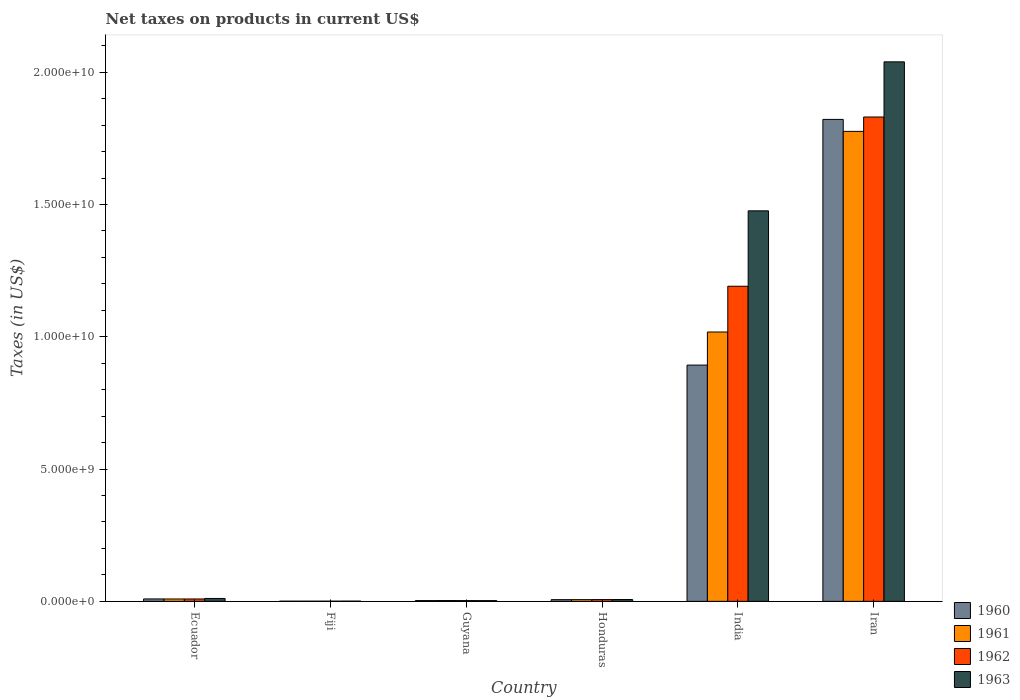How many groups of bars are there?
Offer a very short reply. 6. Are the number of bars per tick equal to the number of legend labels?
Keep it short and to the point. Yes. Are the number of bars on each tick of the X-axis equal?
Make the answer very short. Yes. What is the label of the 2nd group of bars from the left?
Keep it short and to the point. Fiji. In how many cases, is the number of bars for a given country not equal to the number of legend labels?
Make the answer very short. 0. What is the net taxes on products in 1963 in Guyana?
Offer a very short reply. 2.82e+07. Across all countries, what is the maximum net taxes on products in 1961?
Keep it short and to the point. 1.78e+1. Across all countries, what is the minimum net taxes on products in 1963?
Make the answer very short. 8.90e+06. In which country was the net taxes on products in 1961 maximum?
Provide a short and direct response. Iran. In which country was the net taxes on products in 1963 minimum?
Provide a succinct answer. Fiji. What is the total net taxes on products in 1960 in the graph?
Make the answer very short. 2.73e+1. What is the difference between the net taxes on products in 1962 in Guyana and that in Honduras?
Offer a very short reply. -3.83e+07. What is the difference between the net taxes on products in 1960 in Iran and the net taxes on products in 1962 in Fiji?
Ensure brevity in your answer.  1.82e+1. What is the average net taxes on products in 1961 per country?
Make the answer very short. 4.69e+09. What is the difference between the net taxes on products of/in 1963 and net taxes on products of/in 1961 in Iran?
Offer a very short reply. 2.63e+09. What is the ratio of the net taxes on products in 1962 in Ecuador to that in Guyana?
Provide a succinct answer. 3.11. What is the difference between the highest and the second highest net taxes on products in 1963?
Provide a succinct answer. 1.47e+1. What is the difference between the highest and the lowest net taxes on products in 1961?
Offer a terse response. 1.78e+1. Is it the case that in every country, the sum of the net taxes on products in 1962 and net taxes on products in 1961 is greater than the sum of net taxes on products in 1960 and net taxes on products in 1963?
Offer a very short reply. No. Is it the case that in every country, the sum of the net taxes on products in 1960 and net taxes on products in 1961 is greater than the net taxes on products in 1963?
Give a very brief answer. Yes. How many bars are there?
Ensure brevity in your answer.  24. Are all the bars in the graph horizontal?
Ensure brevity in your answer.  No. Are the values on the major ticks of Y-axis written in scientific E-notation?
Ensure brevity in your answer.  Yes. Does the graph contain grids?
Keep it short and to the point. No. What is the title of the graph?
Provide a short and direct response. Net taxes on products in current US$. What is the label or title of the X-axis?
Your response must be concise. Country. What is the label or title of the Y-axis?
Your answer should be very brief. Taxes (in US$). What is the Taxes (in US$) of 1960 in Ecuador?
Offer a very short reply. 9.19e+07. What is the Taxes (in US$) of 1961 in Ecuador?
Give a very brief answer. 9.02e+07. What is the Taxes (in US$) of 1962 in Ecuador?
Your response must be concise. 9.02e+07. What is the Taxes (in US$) in 1963 in Ecuador?
Keep it short and to the point. 1.10e+08. What is the Taxes (in US$) of 1960 in Fiji?
Offer a very short reply. 6.80e+06. What is the Taxes (in US$) in 1961 in Fiji?
Ensure brevity in your answer.  6.80e+06. What is the Taxes (in US$) of 1962 in Fiji?
Your answer should be very brief. 7.40e+06. What is the Taxes (in US$) of 1963 in Fiji?
Offer a terse response. 8.90e+06. What is the Taxes (in US$) in 1960 in Guyana?
Your answer should be compact. 2.94e+07. What is the Taxes (in US$) of 1961 in Guyana?
Offer a very short reply. 3.07e+07. What is the Taxes (in US$) in 1962 in Guyana?
Your response must be concise. 2.90e+07. What is the Taxes (in US$) in 1963 in Guyana?
Your answer should be very brief. 2.82e+07. What is the Taxes (in US$) of 1960 in Honduras?
Offer a terse response. 6.45e+07. What is the Taxes (in US$) in 1961 in Honduras?
Make the answer very short. 6.50e+07. What is the Taxes (in US$) of 1962 in Honduras?
Provide a succinct answer. 6.73e+07. What is the Taxes (in US$) in 1963 in Honduras?
Ensure brevity in your answer.  6.96e+07. What is the Taxes (in US$) in 1960 in India?
Your response must be concise. 8.93e+09. What is the Taxes (in US$) of 1961 in India?
Your answer should be compact. 1.02e+1. What is the Taxes (in US$) in 1962 in India?
Provide a short and direct response. 1.19e+1. What is the Taxes (in US$) of 1963 in India?
Your response must be concise. 1.48e+1. What is the Taxes (in US$) in 1960 in Iran?
Give a very brief answer. 1.82e+1. What is the Taxes (in US$) in 1961 in Iran?
Ensure brevity in your answer.  1.78e+1. What is the Taxes (in US$) of 1962 in Iran?
Your answer should be compact. 1.83e+1. What is the Taxes (in US$) in 1963 in Iran?
Ensure brevity in your answer.  2.04e+1. Across all countries, what is the maximum Taxes (in US$) of 1960?
Provide a succinct answer. 1.82e+1. Across all countries, what is the maximum Taxes (in US$) of 1961?
Provide a short and direct response. 1.78e+1. Across all countries, what is the maximum Taxes (in US$) in 1962?
Your answer should be very brief. 1.83e+1. Across all countries, what is the maximum Taxes (in US$) in 1963?
Your response must be concise. 2.04e+1. Across all countries, what is the minimum Taxes (in US$) of 1960?
Ensure brevity in your answer.  6.80e+06. Across all countries, what is the minimum Taxes (in US$) in 1961?
Keep it short and to the point. 6.80e+06. Across all countries, what is the minimum Taxes (in US$) in 1962?
Provide a succinct answer. 7.40e+06. Across all countries, what is the minimum Taxes (in US$) of 1963?
Ensure brevity in your answer.  8.90e+06. What is the total Taxes (in US$) in 1960 in the graph?
Offer a very short reply. 2.73e+1. What is the total Taxes (in US$) in 1961 in the graph?
Ensure brevity in your answer.  2.81e+1. What is the total Taxes (in US$) of 1962 in the graph?
Your answer should be compact. 3.04e+1. What is the total Taxes (in US$) in 1963 in the graph?
Make the answer very short. 3.54e+1. What is the difference between the Taxes (in US$) in 1960 in Ecuador and that in Fiji?
Your response must be concise. 8.51e+07. What is the difference between the Taxes (in US$) in 1961 in Ecuador and that in Fiji?
Your response must be concise. 8.34e+07. What is the difference between the Taxes (in US$) in 1962 in Ecuador and that in Fiji?
Offer a terse response. 8.28e+07. What is the difference between the Taxes (in US$) in 1963 in Ecuador and that in Fiji?
Make the answer very short. 1.01e+08. What is the difference between the Taxes (in US$) in 1960 in Ecuador and that in Guyana?
Ensure brevity in your answer.  6.25e+07. What is the difference between the Taxes (in US$) in 1961 in Ecuador and that in Guyana?
Your response must be concise. 5.95e+07. What is the difference between the Taxes (in US$) of 1962 in Ecuador and that in Guyana?
Your response must be concise. 6.12e+07. What is the difference between the Taxes (in US$) of 1963 in Ecuador and that in Guyana?
Your response must be concise. 8.15e+07. What is the difference between the Taxes (in US$) in 1960 in Ecuador and that in Honduras?
Ensure brevity in your answer.  2.74e+07. What is the difference between the Taxes (in US$) of 1961 in Ecuador and that in Honduras?
Provide a succinct answer. 2.52e+07. What is the difference between the Taxes (in US$) in 1962 in Ecuador and that in Honduras?
Your answer should be compact. 2.29e+07. What is the difference between the Taxes (in US$) in 1963 in Ecuador and that in Honduras?
Your response must be concise. 4.01e+07. What is the difference between the Taxes (in US$) in 1960 in Ecuador and that in India?
Your answer should be very brief. -8.84e+09. What is the difference between the Taxes (in US$) of 1961 in Ecuador and that in India?
Your answer should be compact. -1.01e+1. What is the difference between the Taxes (in US$) of 1962 in Ecuador and that in India?
Your response must be concise. -1.18e+1. What is the difference between the Taxes (in US$) in 1963 in Ecuador and that in India?
Give a very brief answer. -1.47e+1. What is the difference between the Taxes (in US$) of 1960 in Ecuador and that in Iran?
Keep it short and to the point. -1.81e+1. What is the difference between the Taxes (in US$) of 1961 in Ecuador and that in Iran?
Provide a short and direct response. -1.77e+1. What is the difference between the Taxes (in US$) in 1962 in Ecuador and that in Iran?
Keep it short and to the point. -1.82e+1. What is the difference between the Taxes (in US$) of 1963 in Ecuador and that in Iran?
Make the answer very short. -2.03e+1. What is the difference between the Taxes (in US$) of 1960 in Fiji and that in Guyana?
Your answer should be very brief. -2.26e+07. What is the difference between the Taxes (in US$) in 1961 in Fiji and that in Guyana?
Keep it short and to the point. -2.39e+07. What is the difference between the Taxes (in US$) of 1962 in Fiji and that in Guyana?
Offer a terse response. -2.16e+07. What is the difference between the Taxes (in US$) in 1963 in Fiji and that in Guyana?
Your answer should be very brief. -1.93e+07. What is the difference between the Taxes (in US$) of 1960 in Fiji and that in Honduras?
Ensure brevity in your answer.  -5.77e+07. What is the difference between the Taxes (in US$) in 1961 in Fiji and that in Honduras?
Your answer should be very brief. -5.82e+07. What is the difference between the Taxes (in US$) of 1962 in Fiji and that in Honduras?
Provide a succinct answer. -5.99e+07. What is the difference between the Taxes (in US$) in 1963 in Fiji and that in Honduras?
Keep it short and to the point. -6.07e+07. What is the difference between the Taxes (in US$) in 1960 in Fiji and that in India?
Your response must be concise. -8.92e+09. What is the difference between the Taxes (in US$) in 1961 in Fiji and that in India?
Make the answer very short. -1.02e+1. What is the difference between the Taxes (in US$) of 1962 in Fiji and that in India?
Your response must be concise. -1.19e+1. What is the difference between the Taxes (in US$) in 1963 in Fiji and that in India?
Keep it short and to the point. -1.48e+1. What is the difference between the Taxes (in US$) of 1960 in Fiji and that in Iran?
Make the answer very short. -1.82e+1. What is the difference between the Taxes (in US$) in 1961 in Fiji and that in Iran?
Make the answer very short. -1.78e+1. What is the difference between the Taxes (in US$) of 1962 in Fiji and that in Iran?
Your response must be concise. -1.83e+1. What is the difference between the Taxes (in US$) in 1963 in Fiji and that in Iran?
Your response must be concise. -2.04e+1. What is the difference between the Taxes (in US$) in 1960 in Guyana and that in Honduras?
Give a very brief answer. -3.51e+07. What is the difference between the Taxes (in US$) in 1961 in Guyana and that in Honduras?
Your response must be concise. -3.43e+07. What is the difference between the Taxes (in US$) in 1962 in Guyana and that in Honduras?
Give a very brief answer. -3.83e+07. What is the difference between the Taxes (in US$) of 1963 in Guyana and that in Honduras?
Offer a very short reply. -4.14e+07. What is the difference between the Taxes (in US$) in 1960 in Guyana and that in India?
Offer a very short reply. -8.90e+09. What is the difference between the Taxes (in US$) of 1961 in Guyana and that in India?
Offer a very short reply. -1.01e+1. What is the difference between the Taxes (in US$) of 1962 in Guyana and that in India?
Your answer should be very brief. -1.19e+1. What is the difference between the Taxes (in US$) of 1963 in Guyana and that in India?
Your answer should be compact. -1.47e+1. What is the difference between the Taxes (in US$) of 1960 in Guyana and that in Iran?
Provide a short and direct response. -1.82e+1. What is the difference between the Taxes (in US$) in 1961 in Guyana and that in Iran?
Your answer should be very brief. -1.77e+1. What is the difference between the Taxes (in US$) in 1962 in Guyana and that in Iran?
Make the answer very short. -1.83e+1. What is the difference between the Taxes (in US$) of 1963 in Guyana and that in Iran?
Your answer should be very brief. -2.04e+1. What is the difference between the Taxes (in US$) of 1960 in Honduras and that in India?
Provide a succinct answer. -8.87e+09. What is the difference between the Taxes (in US$) of 1961 in Honduras and that in India?
Your answer should be very brief. -1.01e+1. What is the difference between the Taxes (in US$) in 1962 in Honduras and that in India?
Provide a succinct answer. -1.18e+1. What is the difference between the Taxes (in US$) in 1963 in Honduras and that in India?
Your answer should be compact. -1.47e+1. What is the difference between the Taxes (in US$) of 1960 in Honduras and that in Iran?
Ensure brevity in your answer.  -1.82e+1. What is the difference between the Taxes (in US$) in 1961 in Honduras and that in Iran?
Provide a short and direct response. -1.77e+1. What is the difference between the Taxes (in US$) in 1962 in Honduras and that in Iran?
Your response must be concise. -1.82e+1. What is the difference between the Taxes (in US$) in 1963 in Honduras and that in Iran?
Your answer should be compact. -2.03e+1. What is the difference between the Taxes (in US$) of 1960 in India and that in Iran?
Provide a short and direct response. -9.29e+09. What is the difference between the Taxes (in US$) in 1961 in India and that in Iran?
Provide a succinct answer. -7.58e+09. What is the difference between the Taxes (in US$) of 1962 in India and that in Iran?
Your answer should be very brief. -6.40e+09. What is the difference between the Taxes (in US$) of 1963 in India and that in Iran?
Provide a short and direct response. -5.63e+09. What is the difference between the Taxes (in US$) in 1960 in Ecuador and the Taxes (in US$) in 1961 in Fiji?
Offer a very short reply. 8.51e+07. What is the difference between the Taxes (in US$) of 1960 in Ecuador and the Taxes (in US$) of 1962 in Fiji?
Offer a very short reply. 8.45e+07. What is the difference between the Taxes (in US$) of 1960 in Ecuador and the Taxes (in US$) of 1963 in Fiji?
Ensure brevity in your answer.  8.30e+07. What is the difference between the Taxes (in US$) of 1961 in Ecuador and the Taxes (in US$) of 1962 in Fiji?
Provide a short and direct response. 8.28e+07. What is the difference between the Taxes (in US$) of 1961 in Ecuador and the Taxes (in US$) of 1963 in Fiji?
Make the answer very short. 8.13e+07. What is the difference between the Taxes (in US$) of 1962 in Ecuador and the Taxes (in US$) of 1963 in Fiji?
Keep it short and to the point. 8.13e+07. What is the difference between the Taxes (in US$) in 1960 in Ecuador and the Taxes (in US$) in 1961 in Guyana?
Offer a terse response. 6.12e+07. What is the difference between the Taxes (in US$) of 1960 in Ecuador and the Taxes (in US$) of 1962 in Guyana?
Your response must be concise. 6.29e+07. What is the difference between the Taxes (in US$) in 1960 in Ecuador and the Taxes (in US$) in 1963 in Guyana?
Provide a succinct answer. 6.37e+07. What is the difference between the Taxes (in US$) of 1961 in Ecuador and the Taxes (in US$) of 1962 in Guyana?
Provide a succinct answer. 6.12e+07. What is the difference between the Taxes (in US$) in 1961 in Ecuador and the Taxes (in US$) in 1963 in Guyana?
Ensure brevity in your answer.  6.20e+07. What is the difference between the Taxes (in US$) in 1962 in Ecuador and the Taxes (in US$) in 1963 in Guyana?
Your response must be concise. 6.20e+07. What is the difference between the Taxes (in US$) in 1960 in Ecuador and the Taxes (in US$) in 1961 in Honduras?
Provide a short and direct response. 2.69e+07. What is the difference between the Taxes (in US$) of 1960 in Ecuador and the Taxes (in US$) of 1962 in Honduras?
Your answer should be very brief. 2.46e+07. What is the difference between the Taxes (in US$) in 1960 in Ecuador and the Taxes (in US$) in 1963 in Honduras?
Your answer should be very brief. 2.23e+07. What is the difference between the Taxes (in US$) in 1961 in Ecuador and the Taxes (in US$) in 1962 in Honduras?
Offer a terse response. 2.29e+07. What is the difference between the Taxes (in US$) of 1961 in Ecuador and the Taxes (in US$) of 1963 in Honduras?
Give a very brief answer. 2.06e+07. What is the difference between the Taxes (in US$) of 1962 in Ecuador and the Taxes (in US$) of 1963 in Honduras?
Keep it short and to the point. 2.06e+07. What is the difference between the Taxes (in US$) in 1960 in Ecuador and the Taxes (in US$) in 1961 in India?
Make the answer very short. -1.01e+1. What is the difference between the Taxes (in US$) in 1960 in Ecuador and the Taxes (in US$) in 1962 in India?
Your answer should be compact. -1.18e+1. What is the difference between the Taxes (in US$) in 1960 in Ecuador and the Taxes (in US$) in 1963 in India?
Keep it short and to the point. -1.47e+1. What is the difference between the Taxes (in US$) in 1961 in Ecuador and the Taxes (in US$) in 1962 in India?
Your answer should be compact. -1.18e+1. What is the difference between the Taxes (in US$) of 1961 in Ecuador and the Taxes (in US$) of 1963 in India?
Provide a succinct answer. -1.47e+1. What is the difference between the Taxes (in US$) in 1962 in Ecuador and the Taxes (in US$) in 1963 in India?
Provide a succinct answer. -1.47e+1. What is the difference between the Taxes (in US$) in 1960 in Ecuador and the Taxes (in US$) in 1961 in Iran?
Your answer should be very brief. -1.77e+1. What is the difference between the Taxes (in US$) of 1960 in Ecuador and the Taxes (in US$) of 1962 in Iran?
Provide a succinct answer. -1.82e+1. What is the difference between the Taxes (in US$) of 1960 in Ecuador and the Taxes (in US$) of 1963 in Iran?
Offer a terse response. -2.03e+1. What is the difference between the Taxes (in US$) in 1961 in Ecuador and the Taxes (in US$) in 1962 in Iran?
Give a very brief answer. -1.82e+1. What is the difference between the Taxes (in US$) of 1961 in Ecuador and the Taxes (in US$) of 1963 in Iran?
Provide a succinct answer. -2.03e+1. What is the difference between the Taxes (in US$) of 1962 in Ecuador and the Taxes (in US$) of 1963 in Iran?
Ensure brevity in your answer.  -2.03e+1. What is the difference between the Taxes (in US$) of 1960 in Fiji and the Taxes (in US$) of 1961 in Guyana?
Your response must be concise. -2.39e+07. What is the difference between the Taxes (in US$) of 1960 in Fiji and the Taxes (in US$) of 1962 in Guyana?
Offer a very short reply. -2.22e+07. What is the difference between the Taxes (in US$) in 1960 in Fiji and the Taxes (in US$) in 1963 in Guyana?
Keep it short and to the point. -2.14e+07. What is the difference between the Taxes (in US$) of 1961 in Fiji and the Taxes (in US$) of 1962 in Guyana?
Your response must be concise. -2.22e+07. What is the difference between the Taxes (in US$) in 1961 in Fiji and the Taxes (in US$) in 1963 in Guyana?
Offer a terse response. -2.14e+07. What is the difference between the Taxes (in US$) of 1962 in Fiji and the Taxes (in US$) of 1963 in Guyana?
Give a very brief answer. -2.08e+07. What is the difference between the Taxes (in US$) of 1960 in Fiji and the Taxes (in US$) of 1961 in Honduras?
Make the answer very short. -5.82e+07. What is the difference between the Taxes (in US$) in 1960 in Fiji and the Taxes (in US$) in 1962 in Honduras?
Offer a very short reply. -6.05e+07. What is the difference between the Taxes (in US$) of 1960 in Fiji and the Taxes (in US$) of 1963 in Honduras?
Your answer should be very brief. -6.28e+07. What is the difference between the Taxes (in US$) in 1961 in Fiji and the Taxes (in US$) in 1962 in Honduras?
Provide a short and direct response. -6.05e+07. What is the difference between the Taxes (in US$) of 1961 in Fiji and the Taxes (in US$) of 1963 in Honduras?
Offer a very short reply. -6.28e+07. What is the difference between the Taxes (in US$) in 1962 in Fiji and the Taxes (in US$) in 1963 in Honduras?
Your response must be concise. -6.22e+07. What is the difference between the Taxes (in US$) of 1960 in Fiji and the Taxes (in US$) of 1961 in India?
Your answer should be very brief. -1.02e+1. What is the difference between the Taxes (in US$) in 1960 in Fiji and the Taxes (in US$) in 1962 in India?
Provide a succinct answer. -1.19e+1. What is the difference between the Taxes (in US$) in 1960 in Fiji and the Taxes (in US$) in 1963 in India?
Give a very brief answer. -1.48e+1. What is the difference between the Taxes (in US$) in 1961 in Fiji and the Taxes (in US$) in 1962 in India?
Ensure brevity in your answer.  -1.19e+1. What is the difference between the Taxes (in US$) in 1961 in Fiji and the Taxes (in US$) in 1963 in India?
Your answer should be compact. -1.48e+1. What is the difference between the Taxes (in US$) in 1962 in Fiji and the Taxes (in US$) in 1963 in India?
Offer a very short reply. -1.48e+1. What is the difference between the Taxes (in US$) of 1960 in Fiji and the Taxes (in US$) of 1961 in Iran?
Your response must be concise. -1.78e+1. What is the difference between the Taxes (in US$) of 1960 in Fiji and the Taxes (in US$) of 1962 in Iran?
Provide a succinct answer. -1.83e+1. What is the difference between the Taxes (in US$) in 1960 in Fiji and the Taxes (in US$) in 1963 in Iran?
Offer a very short reply. -2.04e+1. What is the difference between the Taxes (in US$) in 1961 in Fiji and the Taxes (in US$) in 1962 in Iran?
Provide a succinct answer. -1.83e+1. What is the difference between the Taxes (in US$) in 1961 in Fiji and the Taxes (in US$) in 1963 in Iran?
Make the answer very short. -2.04e+1. What is the difference between the Taxes (in US$) in 1962 in Fiji and the Taxes (in US$) in 1963 in Iran?
Your answer should be very brief. -2.04e+1. What is the difference between the Taxes (in US$) of 1960 in Guyana and the Taxes (in US$) of 1961 in Honduras?
Your response must be concise. -3.56e+07. What is the difference between the Taxes (in US$) in 1960 in Guyana and the Taxes (in US$) in 1962 in Honduras?
Your answer should be very brief. -3.79e+07. What is the difference between the Taxes (in US$) in 1960 in Guyana and the Taxes (in US$) in 1963 in Honduras?
Provide a short and direct response. -4.02e+07. What is the difference between the Taxes (in US$) of 1961 in Guyana and the Taxes (in US$) of 1962 in Honduras?
Ensure brevity in your answer.  -3.66e+07. What is the difference between the Taxes (in US$) of 1961 in Guyana and the Taxes (in US$) of 1963 in Honduras?
Your answer should be very brief. -3.89e+07. What is the difference between the Taxes (in US$) of 1962 in Guyana and the Taxes (in US$) of 1963 in Honduras?
Keep it short and to the point. -4.06e+07. What is the difference between the Taxes (in US$) in 1960 in Guyana and the Taxes (in US$) in 1961 in India?
Provide a short and direct response. -1.02e+1. What is the difference between the Taxes (in US$) of 1960 in Guyana and the Taxes (in US$) of 1962 in India?
Provide a succinct answer. -1.19e+1. What is the difference between the Taxes (in US$) in 1960 in Guyana and the Taxes (in US$) in 1963 in India?
Provide a succinct answer. -1.47e+1. What is the difference between the Taxes (in US$) in 1961 in Guyana and the Taxes (in US$) in 1962 in India?
Give a very brief answer. -1.19e+1. What is the difference between the Taxes (in US$) of 1961 in Guyana and the Taxes (in US$) of 1963 in India?
Make the answer very short. -1.47e+1. What is the difference between the Taxes (in US$) in 1962 in Guyana and the Taxes (in US$) in 1963 in India?
Provide a short and direct response. -1.47e+1. What is the difference between the Taxes (in US$) of 1960 in Guyana and the Taxes (in US$) of 1961 in Iran?
Ensure brevity in your answer.  -1.77e+1. What is the difference between the Taxes (in US$) in 1960 in Guyana and the Taxes (in US$) in 1962 in Iran?
Give a very brief answer. -1.83e+1. What is the difference between the Taxes (in US$) in 1960 in Guyana and the Taxes (in US$) in 1963 in Iran?
Keep it short and to the point. -2.04e+1. What is the difference between the Taxes (in US$) of 1961 in Guyana and the Taxes (in US$) of 1962 in Iran?
Ensure brevity in your answer.  -1.83e+1. What is the difference between the Taxes (in US$) of 1961 in Guyana and the Taxes (in US$) of 1963 in Iran?
Your response must be concise. -2.04e+1. What is the difference between the Taxes (in US$) in 1962 in Guyana and the Taxes (in US$) in 1963 in Iran?
Give a very brief answer. -2.04e+1. What is the difference between the Taxes (in US$) in 1960 in Honduras and the Taxes (in US$) in 1961 in India?
Provide a short and direct response. -1.01e+1. What is the difference between the Taxes (in US$) of 1960 in Honduras and the Taxes (in US$) of 1962 in India?
Keep it short and to the point. -1.18e+1. What is the difference between the Taxes (in US$) of 1960 in Honduras and the Taxes (in US$) of 1963 in India?
Your answer should be very brief. -1.47e+1. What is the difference between the Taxes (in US$) in 1961 in Honduras and the Taxes (in US$) in 1962 in India?
Keep it short and to the point. -1.18e+1. What is the difference between the Taxes (in US$) of 1961 in Honduras and the Taxes (in US$) of 1963 in India?
Give a very brief answer. -1.47e+1. What is the difference between the Taxes (in US$) of 1962 in Honduras and the Taxes (in US$) of 1963 in India?
Offer a very short reply. -1.47e+1. What is the difference between the Taxes (in US$) in 1960 in Honduras and the Taxes (in US$) in 1961 in Iran?
Your answer should be compact. -1.77e+1. What is the difference between the Taxes (in US$) in 1960 in Honduras and the Taxes (in US$) in 1962 in Iran?
Give a very brief answer. -1.82e+1. What is the difference between the Taxes (in US$) of 1960 in Honduras and the Taxes (in US$) of 1963 in Iran?
Give a very brief answer. -2.03e+1. What is the difference between the Taxes (in US$) of 1961 in Honduras and the Taxes (in US$) of 1962 in Iran?
Ensure brevity in your answer.  -1.82e+1. What is the difference between the Taxes (in US$) of 1961 in Honduras and the Taxes (in US$) of 1963 in Iran?
Your answer should be compact. -2.03e+1. What is the difference between the Taxes (in US$) in 1962 in Honduras and the Taxes (in US$) in 1963 in Iran?
Provide a succinct answer. -2.03e+1. What is the difference between the Taxes (in US$) of 1960 in India and the Taxes (in US$) of 1961 in Iran?
Offer a very short reply. -8.83e+09. What is the difference between the Taxes (in US$) of 1960 in India and the Taxes (in US$) of 1962 in Iran?
Keep it short and to the point. -9.38e+09. What is the difference between the Taxes (in US$) in 1960 in India and the Taxes (in US$) in 1963 in Iran?
Provide a short and direct response. -1.15e+1. What is the difference between the Taxes (in US$) of 1961 in India and the Taxes (in US$) of 1962 in Iran?
Your answer should be very brief. -8.13e+09. What is the difference between the Taxes (in US$) in 1961 in India and the Taxes (in US$) in 1963 in Iran?
Your response must be concise. -1.02e+1. What is the difference between the Taxes (in US$) of 1962 in India and the Taxes (in US$) of 1963 in Iran?
Your answer should be very brief. -8.48e+09. What is the average Taxes (in US$) in 1960 per country?
Ensure brevity in your answer.  4.56e+09. What is the average Taxes (in US$) in 1961 per country?
Your response must be concise. 4.69e+09. What is the average Taxes (in US$) of 1962 per country?
Your response must be concise. 5.07e+09. What is the average Taxes (in US$) of 1963 per country?
Ensure brevity in your answer.  5.89e+09. What is the difference between the Taxes (in US$) in 1960 and Taxes (in US$) in 1961 in Ecuador?
Make the answer very short. 1.67e+06. What is the difference between the Taxes (in US$) of 1960 and Taxes (in US$) of 1962 in Ecuador?
Your answer should be very brief. 1.67e+06. What is the difference between the Taxes (in US$) in 1960 and Taxes (in US$) in 1963 in Ecuador?
Ensure brevity in your answer.  -1.78e+07. What is the difference between the Taxes (in US$) of 1961 and Taxes (in US$) of 1962 in Ecuador?
Offer a terse response. 0. What is the difference between the Taxes (in US$) in 1961 and Taxes (in US$) in 1963 in Ecuador?
Your response must be concise. -1.95e+07. What is the difference between the Taxes (in US$) of 1962 and Taxes (in US$) of 1963 in Ecuador?
Provide a succinct answer. -1.95e+07. What is the difference between the Taxes (in US$) of 1960 and Taxes (in US$) of 1962 in Fiji?
Give a very brief answer. -6.00e+05. What is the difference between the Taxes (in US$) in 1960 and Taxes (in US$) in 1963 in Fiji?
Keep it short and to the point. -2.10e+06. What is the difference between the Taxes (in US$) of 1961 and Taxes (in US$) of 1962 in Fiji?
Give a very brief answer. -6.00e+05. What is the difference between the Taxes (in US$) of 1961 and Taxes (in US$) of 1963 in Fiji?
Offer a terse response. -2.10e+06. What is the difference between the Taxes (in US$) in 1962 and Taxes (in US$) in 1963 in Fiji?
Provide a short and direct response. -1.50e+06. What is the difference between the Taxes (in US$) in 1960 and Taxes (in US$) in 1961 in Guyana?
Offer a very short reply. -1.30e+06. What is the difference between the Taxes (in US$) in 1960 and Taxes (in US$) in 1963 in Guyana?
Your answer should be very brief. 1.20e+06. What is the difference between the Taxes (in US$) of 1961 and Taxes (in US$) of 1962 in Guyana?
Make the answer very short. 1.70e+06. What is the difference between the Taxes (in US$) of 1961 and Taxes (in US$) of 1963 in Guyana?
Your answer should be very brief. 2.50e+06. What is the difference between the Taxes (in US$) of 1960 and Taxes (in US$) of 1961 in Honduras?
Ensure brevity in your answer.  -5.00e+05. What is the difference between the Taxes (in US$) in 1960 and Taxes (in US$) in 1962 in Honduras?
Provide a short and direct response. -2.80e+06. What is the difference between the Taxes (in US$) of 1960 and Taxes (in US$) of 1963 in Honduras?
Provide a short and direct response. -5.10e+06. What is the difference between the Taxes (in US$) in 1961 and Taxes (in US$) in 1962 in Honduras?
Make the answer very short. -2.30e+06. What is the difference between the Taxes (in US$) of 1961 and Taxes (in US$) of 1963 in Honduras?
Your response must be concise. -4.60e+06. What is the difference between the Taxes (in US$) of 1962 and Taxes (in US$) of 1963 in Honduras?
Your response must be concise. -2.30e+06. What is the difference between the Taxes (in US$) in 1960 and Taxes (in US$) in 1961 in India?
Your answer should be compact. -1.25e+09. What is the difference between the Taxes (in US$) of 1960 and Taxes (in US$) of 1962 in India?
Make the answer very short. -2.98e+09. What is the difference between the Taxes (in US$) in 1960 and Taxes (in US$) in 1963 in India?
Make the answer very short. -5.83e+09. What is the difference between the Taxes (in US$) of 1961 and Taxes (in US$) of 1962 in India?
Make the answer very short. -1.73e+09. What is the difference between the Taxes (in US$) of 1961 and Taxes (in US$) of 1963 in India?
Your answer should be compact. -4.58e+09. What is the difference between the Taxes (in US$) of 1962 and Taxes (in US$) of 1963 in India?
Keep it short and to the point. -2.85e+09. What is the difference between the Taxes (in US$) in 1960 and Taxes (in US$) in 1961 in Iran?
Ensure brevity in your answer.  4.53e+08. What is the difference between the Taxes (in US$) in 1960 and Taxes (in US$) in 1962 in Iran?
Keep it short and to the point. -9.06e+07. What is the difference between the Taxes (in US$) in 1960 and Taxes (in US$) in 1963 in Iran?
Provide a succinct answer. -2.18e+09. What is the difference between the Taxes (in US$) of 1961 and Taxes (in US$) of 1962 in Iran?
Keep it short and to the point. -5.44e+08. What is the difference between the Taxes (in US$) in 1961 and Taxes (in US$) in 1963 in Iran?
Make the answer very short. -2.63e+09. What is the difference between the Taxes (in US$) in 1962 and Taxes (in US$) in 1963 in Iran?
Your answer should be very brief. -2.08e+09. What is the ratio of the Taxes (in US$) of 1960 in Ecuador to that in Fiji?
Offer a very short reply. 13.51. What is the ratio of the Taxes (in US$) in 1961 in Ecuador to that in Fiji?
Keep it short and to the point. 13.27. What is the ratio of the Taxes (in US$) of 1962 in Ecuador to that in Fiji?
Give a very brief answer. 12.19. What is the ratio of the Taxes (in US$) of 1963 in Ecuador to that in Fiji?
Provide a succinct answer. 12.33. What is the ratio of the Taxes (in US$) of 1960 in Ecuador to that in Guyana?
Make the answer very short. 3.13. What is the ratio of the Taxes (in US$) in 1961 in Ecuador to that in Guyana?
Your answer should be very brief. 2.94. What is the ratio of the Taxes (in US$) of 1962 in Ecuador to that in Guyana?
Offer a terse response. 3.11. What is the ratio of the Taxes (in US$) of 1963 in Ecuador to that in Guyana?
Make the answer very short. 3.89. What is the ratio of the Taxes (in US$) in 1960 in Ecuador to that in Honduras?
Provide a short and direct response. 1.42. What is the ratio of the Taxes (in US$) in 1961 in Ecuador to that in Honduras?
Your answer should be very brief. 1.39. What is the ratio of the Taxes (in US$) in 1962 in Ecuador to that in Honduras?
Ensure brevity in your answer.  1.34. What is the ratio of the Taxes (in US$) of 1963 in Ecuador to that in Honduras?
Provide a short and direct response. 1.58. What is the ratio of the Taxes (in US$) of 1960 in Ecuador to that in India?
Offer a very short reply. 0.01. What is the ratio of the Taxes (in US$) in 1961 in Ecuador to that in India?
Offer a terse response. 0.01. What is the ratio of the Taxes (in US$) in 1962 in Ecuador to that in India?
Keep it short and to the point. 0.01. What is the ratio of the Taxes (in US$) in 1963 in Ecuador to that in India?
Offer a very short reply. 0.01. What is the ratio of the Taxes (in US$) of 1960 in Ecuador to that in Iran?
Your response must be concise. 0.01. What is the ratio of the Taxes (in US$) of 1961 in Ecuador to that in Iran?
Offer a very short reply. 0.01. What is the ratio of the Taxes (in US$) of 1962 in Ecuador to that in Iran?
Offer a terse response. 0. What is the ratio of the Taxes (in US$) in 1963 in Ecuador to that in Iran?
Your answer should be compact. 0.01. What is the ratio of the Taxes (in US$) in 1960 in Fiji to that in Guyana?
Provide a short and direct response. 0.23. What is the ratio of the Taxes (in US$) of 1961 in Fiji to that in Guyana?
Your response must be concise. 0.22. What is the ratio of the Taxes (in US$) of 1962 in Fiji to that in Guyana?
Your answer should be very brief. 0.26. What is the ratio of the Taxes (in US$) in 1963 in Fiji to that in Guyana?
Make the answer very short. 0.32. What is the ratio of the Taxes (in US$) of 1960 in Fiji to that in Honduras?
Give a very brief answer. 0.11. What is the ratio of the Taxes (in US$) in 1961 in Fiji to that in Honduras?
Ensure brevity in your answer.  0.1. What is the ratio of the Taxes (in US$) of 1962 in Fiji to that in Honduras?
Provide a succinct answer. 0.11. What is the ratio of the Taxes (in US$) of 1963 in Fiji to that in Honduras?
Your answer should be compact. 0.13. What is the ratio of the Taxes (in US$) in 1960 in Fiji to that in India?
Your answer should be very brief. 0. What is the ratio of the Taxes (in US$) in 1961 in Fiji to that in India?
Give a very brief answer. 0. What is the ratio of the Taxes (in US$) in 1962 in Fiji to that in India?
Offer a very short reply. 0. What is the ratio of the Taxes (in US$) in 1963 in Fiji to that in India?
Provide a succinct answer. 0. What is the ratio of the Taxes (in US$) of 1960 in Guyana to that in Honduras?
Provide a succinct answer. 0.46. What is the ratio of the Taxes (in US$) in 1961 in Guyana to that in Honduras?
Your answer should be compact. 0.47. What is the ratio of the Taxes (in US$) in 1962 in Guyana to that in Honduras?
Your response must be concise. 0.43. What is the ratio of the Taxes (in US$) of 1963 in Guyana to that in Honduras?
Keep it short and to the point. 0.41. What is the ratio of the Taxes (in US$) in 1960 in Guyana to that in India?
Your answer should be very brief. 0. What is the ratio of the Taxes (in US$) of 1961 in Guyana to that in India?
Give a very brief answer. 0. What is the ratio of the Taxes (in US$) of 1962 in Guyana to that in India?
Provide a succinct answer. 0. What is the ratio of the Taxes (in US$) of 1963 in Guyana to that in India?
Your answer should be compact. 0. What is the ratio of the Taxes (in US$) in 1960 in Guyana to that in Iran?
Your response must be concise. 0. What is the ratio of the Taxes (in US$) in 1961 in Guyana to that in Iran?
Offer a very short reply. 0. What is the ratio of the Taxes (in US$) of 1962 in Guyana to that in Iran?
Provide a succinct answer. 0. What is the ratio of the Taxes (in US$) of 1963 in Guyana to that in Iran?
Make the answer very short. 0. What is the ratio of the Taxes (in US$) in 1960 in Honduras to that in India?
Your answer should be compact. 0.01. What is the ratio of the Taxes (in US$) in 1961 in Honduras to that in India?
Make the answer very short. 0.01. What is the ratio of the Taxes (in US$) of 1962 in Honduras to that in India?
Provide a short and direct response. 0.01. What is the ratio of the Taxes (in US$) of 1963 in Honduras to that in India?
Offer a terse response. 0. What is the ratio of the Taxes (in US$) of 1960 in Honduras to that in Iran?
Provide a succinct answer. 0. What is the ratio of the Taxes (in US$) in 1961 in Honduras to that in Iran?
Offer a terse response. 0. What is the ratio of the Taxes (in US$) in 1962 in Honduras to that in Iran?
Your answer should be compact. 0. What is the ratio of the Taxes (in US$) of 1963 in Honduras to that in Iran?
Your answer should be very brief. 0. What is the ratio of the Taxes (in US$) of 1960 in India to that in Iran?
Provide a succinct answer. 0.49. What is the ratio of the Taxes (in US$) in 1961 in India to that in Iran?
Make the answer very short. 0.57. What is the ratio of the Taxes (in US$) of 1962 in India to that in Iran?
Your answer should be compact. 0.65. What is the ratio of the Taxes (in US$) of 1963 in India to that in Iran?
Provide a short and direct response. 0.72. What is the difference between the highest and the second highest Taxes (in US$) in 1960?
Make the answer very short. 9.29e+09. What is the difference between the highest and the second highest Taxes (in US$) of 1961?
Your answer should be very brief. 7.58e+09. What is the difference between the highest and the second highest Taxes (in US$) in 1962?
Keep it short and to the point. 6.40e+09. What is the difference between the highest and the second highest Taxes (in US$) in 1963?
Your response must be concise. 5.63e+09. What is the difference between the highest and the lowest Taxes (in US$) of 1960?
Give a very brief answer. 1.82e+1. What is the difference between the highest and the lowest Taxes (in US$) in 1961?
Offer a terse response. 1.78e+1. What is the difference between the highest and the lowest Taxes (in US$) of 1962?
Your response must be concise. 1.83e+1. What is the difference between the highest and the lowest Taxes (in US$) of 1963?
Keep it short and to the point. 2.04e+1. 